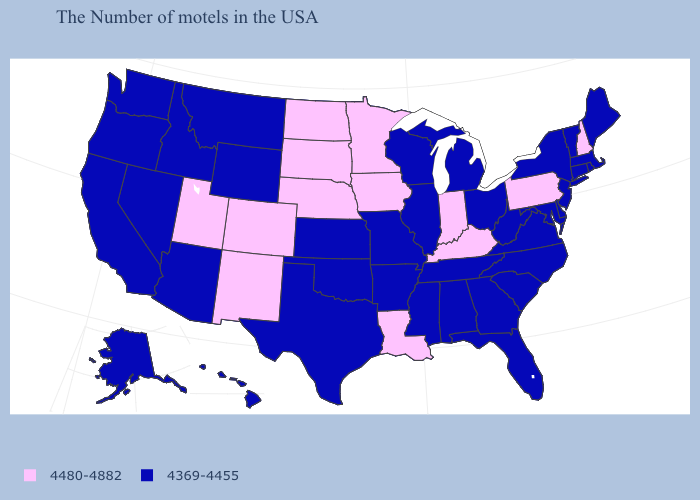Among the states that border Vermont , which have the highest value?
Give a very brief answer. New Hampshire. What is the value of Wisconsin?
Write a very short answer. 4369-4455. Among the states that border Delaware , which have the highest value?
Keep it brief. Pennsylvania. Is the legend a continuous bar?
Concise answer only. No. Name the states that have a value in the range 4369-4455?
Quick response, please. Maine, Massachusetts, Rhode Island, Vermont, Connecticut, New York, New Jersey, Delaware, Maryland, Virginia, North Carolina, South Carolina, West Virginia, Ohio, Florida, Georgia, Michigan, Alabama, Tennessee, Wisconsin, Illinois, Mississippi, Missouri, Arkansas, Kansas, Oklahoma, Texas, Wyoming, Montana, Arizona, Idaho, Nevada, California, Washington, Oregon, Alaska, Hawaii. Does Georgia have a lower value than Minnesota?
Short answer required. Yes. Name the states that have a value in the range 4480-4882?
Short answer required. New Hampshire, Pennsylvania, Kentucky, Indiana, Louisiana, Minnesota, Iowa, Nebraska, South Dakota, North Dakota, Colorado, New Mexico, Utah. What is the lowest value in the MidWest?
Give a very brief answer. 4369-4455. How many symbols are there in the legend?
Concise answer only. 2. What is the value of California?
Be succinct. 4369-4455. Does Massachusetts have the highest value in the USA?
Short answer required. No. What is the highest value in the USA?
Short answer required. 4480-4882. Does Rhode Island have the highest value in the Northeast?
Quick response, please. No. Among the states that border Iowa , does Missouri have the highest value?
Short answer required. No. Name the states that have a value in the range 4369-4455?
Be succinct. Maine, Massachusetts, Rhode Island, Vermont, Connecticut, New York, New Jersey, Delaware, Maryland, Virginia, North Carolina, South Carolina, West Virginia, Ohio, Florida, Georgia, Michigan, Alabama, Tennessee, Wisconsin, Illinois, Mississippi, Missouri, Arkansas, Kansas, Oklahoma, Texas, Wyoming, Montana, Arizona, Idaho, Nevada, California, Washington, Oregon, Alaska, Hawaii. 